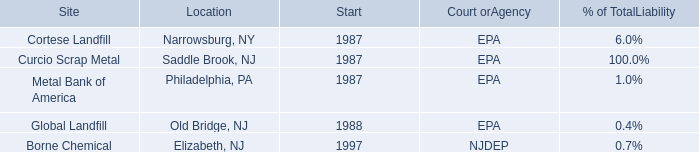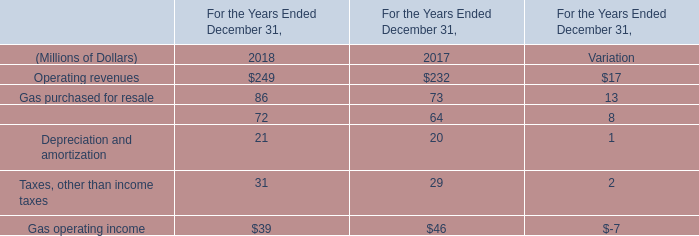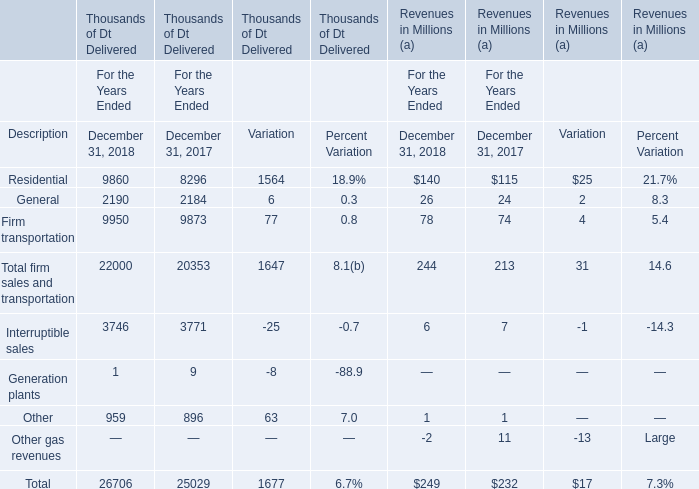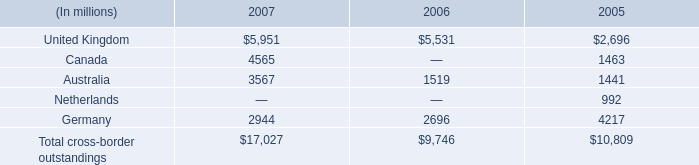What was the total amount of firm sales and transportation of Dt Delivered in 2018? 
Computations: ((9860 + 2190) + 9950)
Answer: 22000.0. 